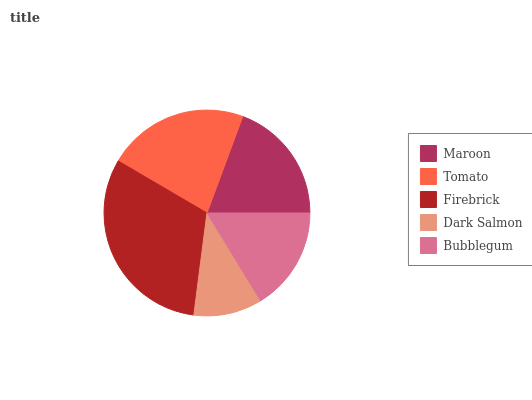Is Dark Salmon the minimum?
Answer yes or no. Yes. Is Firebrick the maximum?
Answer yes or no. Yes. Is Tomato the minimum?
Answer yes or no. No. Is Tomato the maximum?
Answer yes or no. No. Is Tomato greater than Maroon?
Answer yes or no. Yes. Is Maroon less than Tomato?
Answer yes or no. Yes. Is Maroon greater than Tomato?
Answer yes or no. No. Is Tomato less than Maroon?
Answer yes or no. No. Is Maroon the high median?
Answer yes or no. Yes. Is Maroon the low median?
Answer yes or no. Yes. Is Tomato the high median?
Answer yes or no. No. Is Tomato the low median?
Answer yes or no. No. 